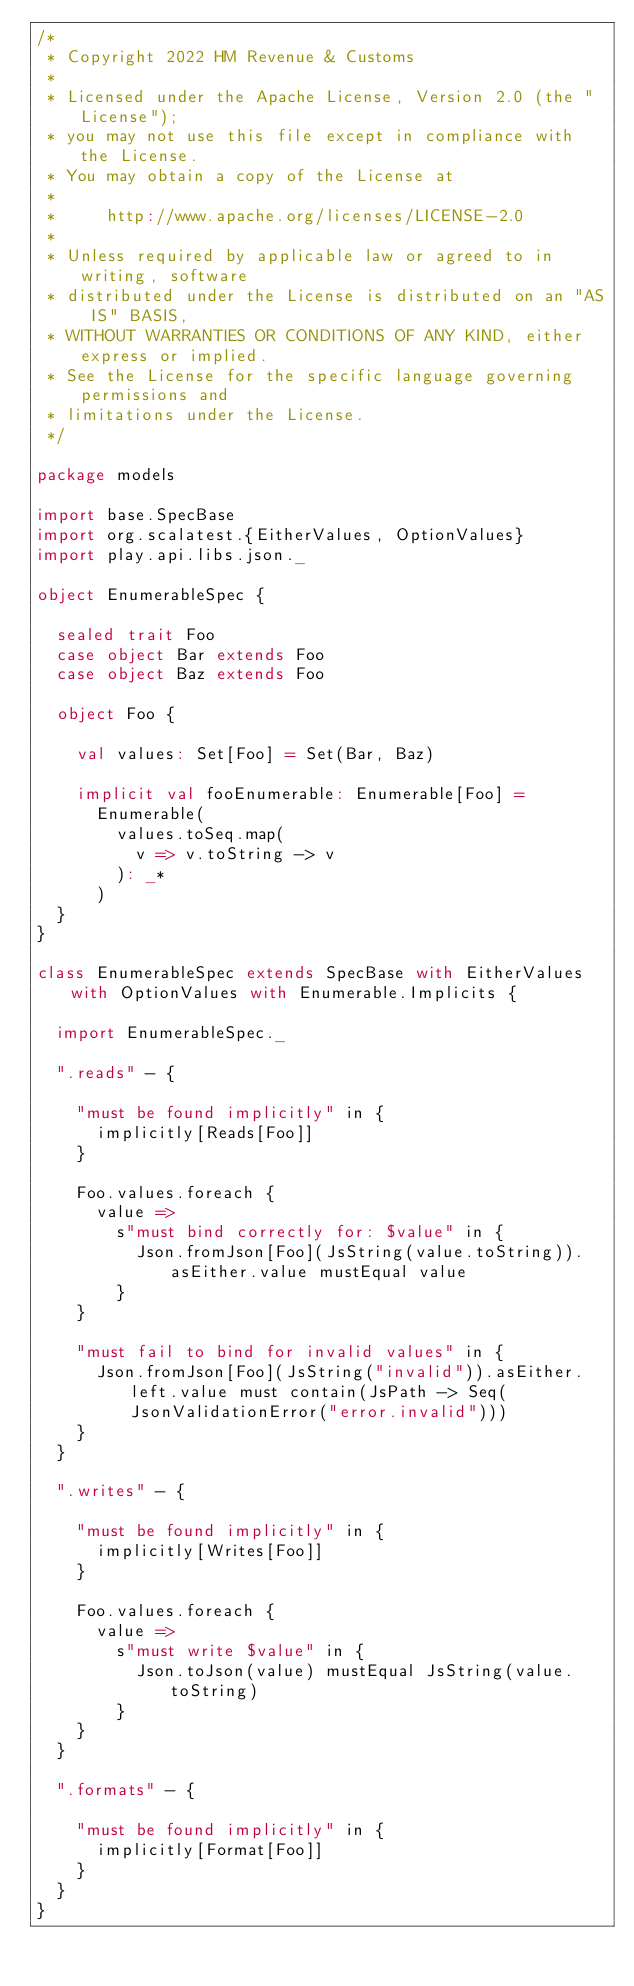Convert code to text. <code><loc_0><loc_0><loc_500><loc_500><_Scala_>/*
 * Copyright 2022 HM Revenue & Customs
 *
 * Licensed under the Apache License, Version 2.0 (the "License");
 * you may not use this file except in compliance with the License.
 * You may obtain a copy of the License at
 *
 *     http://www.apache.org/licenses/LICENSE-2.0
 *
 * Unless required by applicable law or agreed to in writing, software
 * distributed under the License is distributed on an "AS IS" BASIS,
 * WITHOUT WARRANTIES OR CONDITIONS OF ANY KIND, either express or implied.
 * See the License for the specific language governing permissions and
 * limitations under the License.
 */

package models

import base.SpecBase
import org.scalatest.{EitherValues, OptionValues}
import play.api.libs.json._

object EnumerableSpec {

  sealed trait Foo
  case object Bar extends Foo
  case object Baz extends Foo

  object Foo {

    val values: Set[Foo] = Set(Bar, Baz)

    implicit val fooEnumerable: Enumerable[Foo] =
      Enumerable(
        values.toSeq.map(
          v => v.toString -> v
        ): _*
      )
  }
}

class EnumerableSpec extends SpecBase with EitherValues with OptionValues with Enumerable.Implicits {

  import EnumerableSpec._

  ".reads" - {

    "must be found implicitly" in {
      implicitly[Reads[Foo]]
    }

    Foo.values.foreach {
      value =>
        s"must bind correctly for: $value" in {
          Json.fromJson[Foo](JsString(value.toString)).asEither.value mustEqual value
        }
    }

    "must fail to bind for invalid values" in {
      Json.fromJson[Foo](JsString("invalid")).asEither.left.value must contain(JsPath -> Seq(JsonValidationError("error.invalid")))
    }
  }

  ".writes" - {

    "must be found implicitly" in {
      implicitly[Writes[Foo]]
    }

    Foo.values.foreach {
      value =>
        s"must write $value" in {
          Json.toJson(value) mustEqual JsString(value.toString)
        }
    }
  }

  ".formats" - {

    "must be found implicitly" in {
      implicitly[Format[Foo]]
    }
  }
}
</code> 